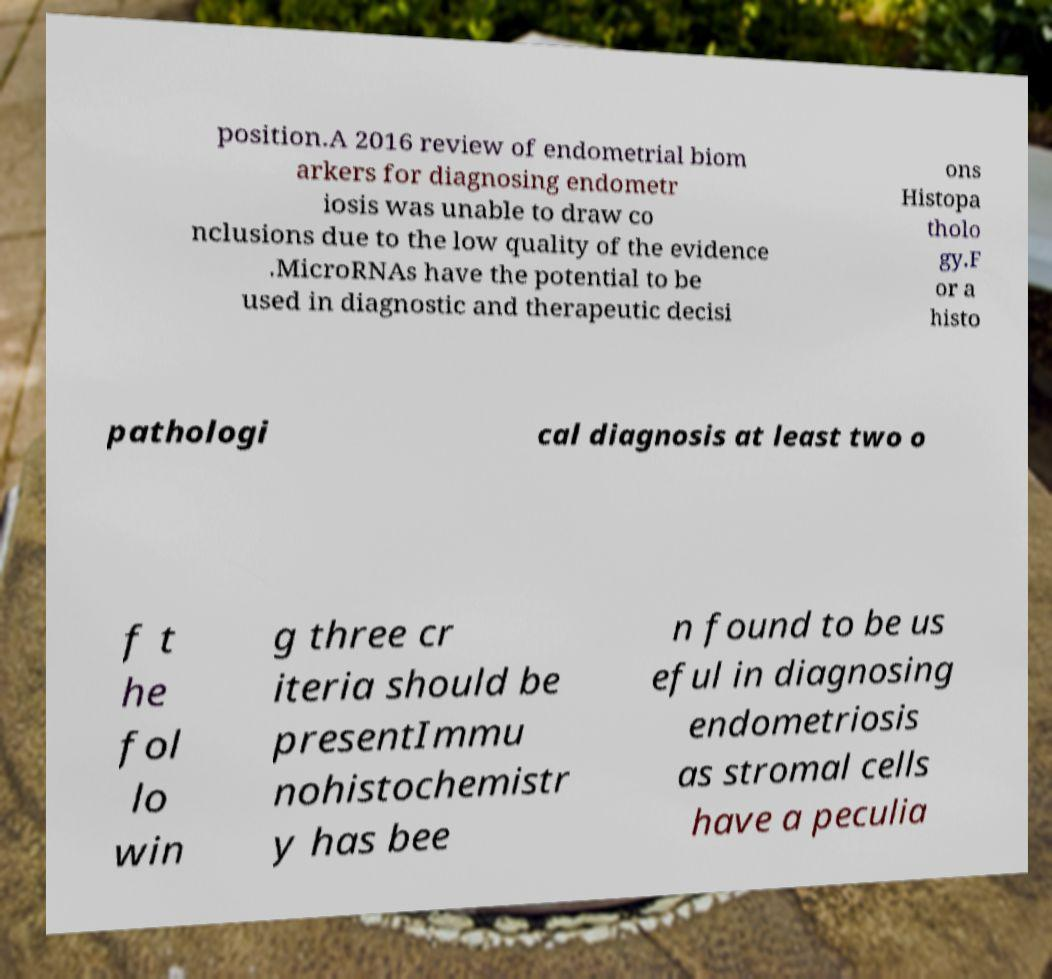Can you read and provide the text displayed in the image?This photo seems to have some interesting text. Can you extract and type it out for me? position.A 2016 review of endometrial biom arkers for diagnosing endometr iosis was unable to draw co nclusions due to the low quality of the evidence .MicroRNAs have the potential to be used in diagnostic and therapeutic decisi ons Histopa tholo gy.F or a histo pathologi cal diagnosis at least two o f t he fol lo win g three cr iteria should be presentImmu nohistochemistr y has bee n found to be us eful in diagnosing endometriosis as stromal cells have a peculia 